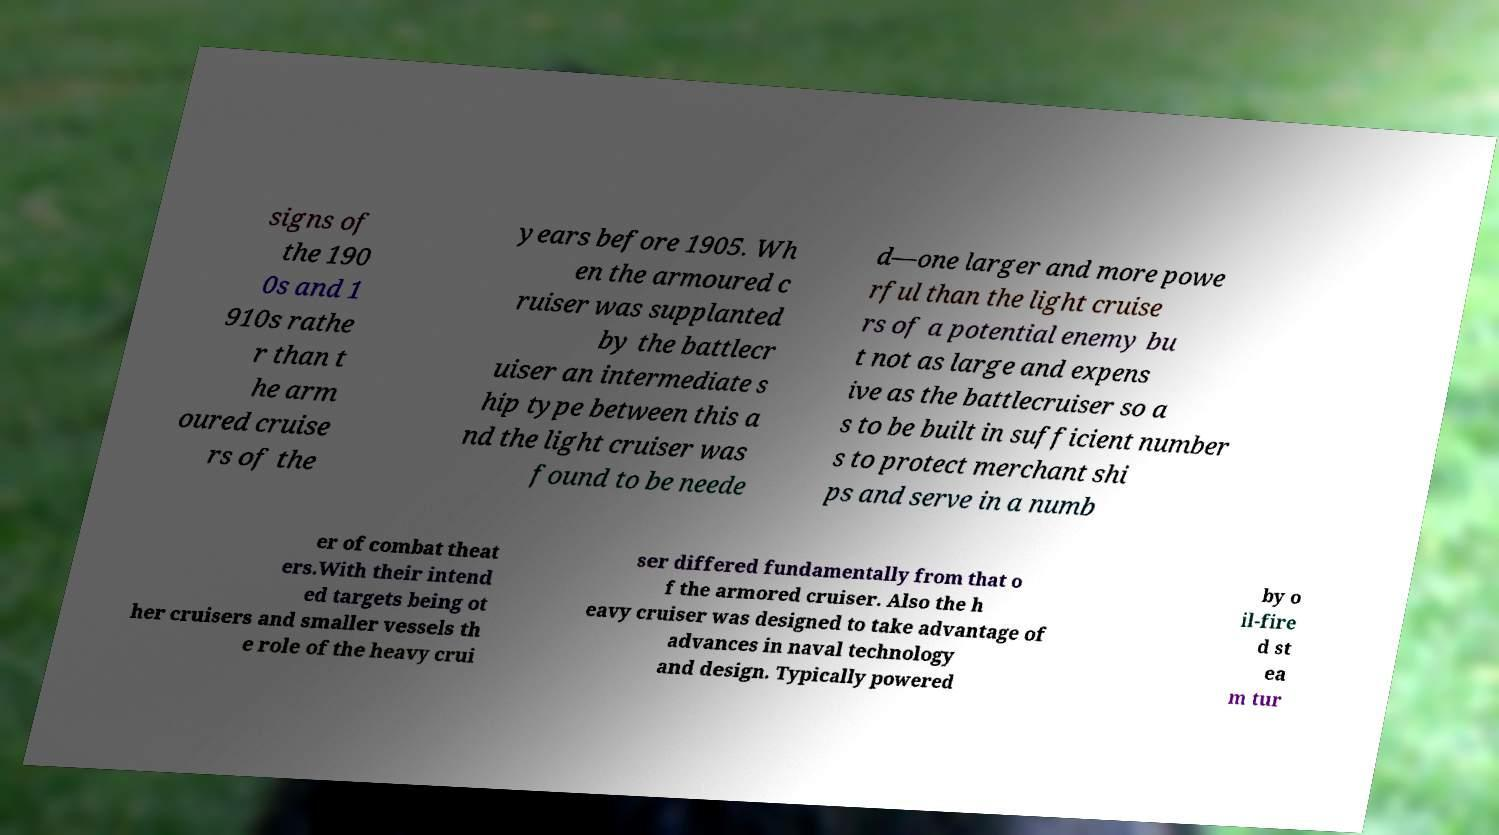Could you assist in decoding the text presented in this image and type it out clearly? signs of the 190 0s and 1 910s rathe r than t he arm oured cruise rs of the years before 1905. Wh en the armoured c ruiser was supplanted by the battlecr uiser an intermediate s hip type between this a nd the light cruiser was found to be neede d—one larger and more powe rful than the light cruise rs of a potential enemy bu t not as large and expens ive as the battlecruiser so a s to be built in sufficient number s to protect merchant shi ps and serve in a numb er of combat theat ers.With their intend ed targets being ot her cruisers and smaller vessels th e role of the heavy crui ser differed fundamentally from that o f the armored cruiser. Also the h eavy cruiser was designed to take advantage of advances in naval technology and design. Typically powered by o il-fire d st ea m tur 